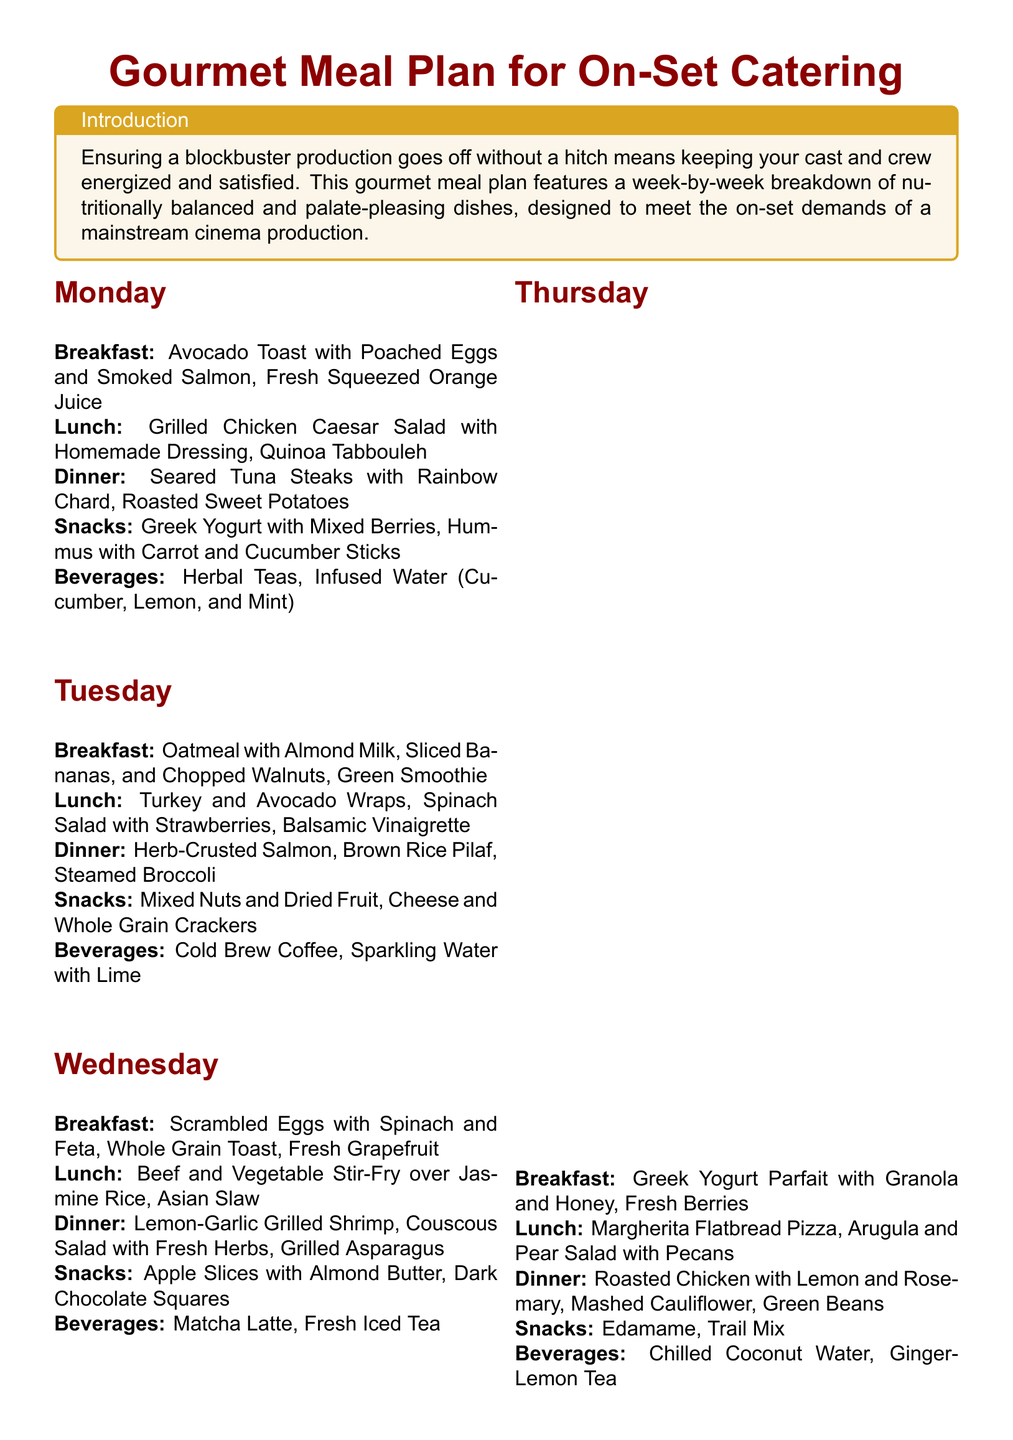what is the breakfast on Monday? The breakfast on Monday is specified in the meal plan as 'Avocado Toast with Poached Eggs and Smoked Salmon, Fresh Squeezed Orange Juice.'
Answer: Avocado Toast with Poached Eggs and Smoked Salmon, Fresh Squeezed Orange Juice what is served for dinner on Friday? The document states that dinner on Friday includes 'Baked Cod with Herb Crust, Orzo with Sundried Tomatoes, Sauteed Spinach.'
Answer: Baked Cod with Herb Crust, Orzo with Sundried Tomatoes, Sauteed Spinach how many meals are listed for each day? The document outlines breakfast, lunch, dinner, snacks, and beverages for each day, totaling five meals.
Answer: Five what snack is offered on Wednesday? The snacks for Wednesday are ‘Apple Slices with Almond Butter, Dark Chocolate Squares’ as per the meal plan.
Answer: Apple Slices with Almond Butter, Dark Chocolate Squares which beverage is served on Thursday? The document specifies that beverages on Thursday are 'Chilled Coconut Water, Ginger-Lemon Tea.'
Answer: Chilled Coconut Water, Ginger-Lemon Tea which day features Shrimp Tacos for lunch? According to the document, Shrimp Tacos are featured in lunch on Sunday.
Answer: Sunday what type of cuisine is emphasized in the meal plan? The plan demonstrates a focus on 'nutritionally balanced and palate-pleasing dishes,' reflecting an effort to cater to diverse dietary preferences.
Answer: Nutritionally balanced and palate-pleasing dishes how is the culinary team characterized in the document? The culinary team is described as being dedicated to 'high-quality, locally sourced ingredients' for the meals prepared.
Answer: High-quality, locally sourced ingredients what is one hydration option listed in the meal plan? The hydration section includes options like 'Herbal Teas, Infused Water (Cucumber, Lemon, and Mint).'
Answer: Herbal Teas, Infused Water (Cucumber, Lemon, and Mint) 